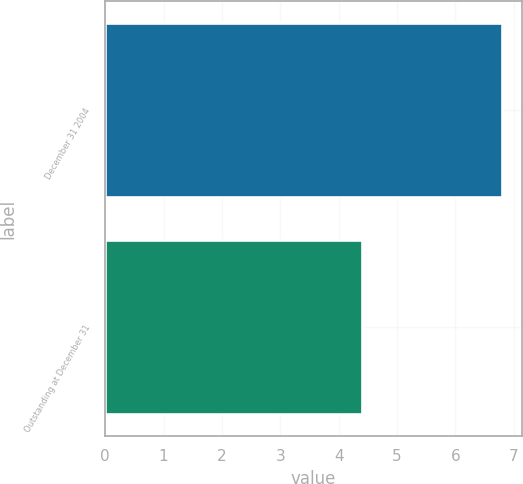Convert chart to OTSL. <chart><loc_0><loc_0><loc_500><loc_500><bar_chart><fcel>December 31 2004<fcel>Outstanding at December 31<nl><fcel>6.8<fcel>4.4<nl></chart> 